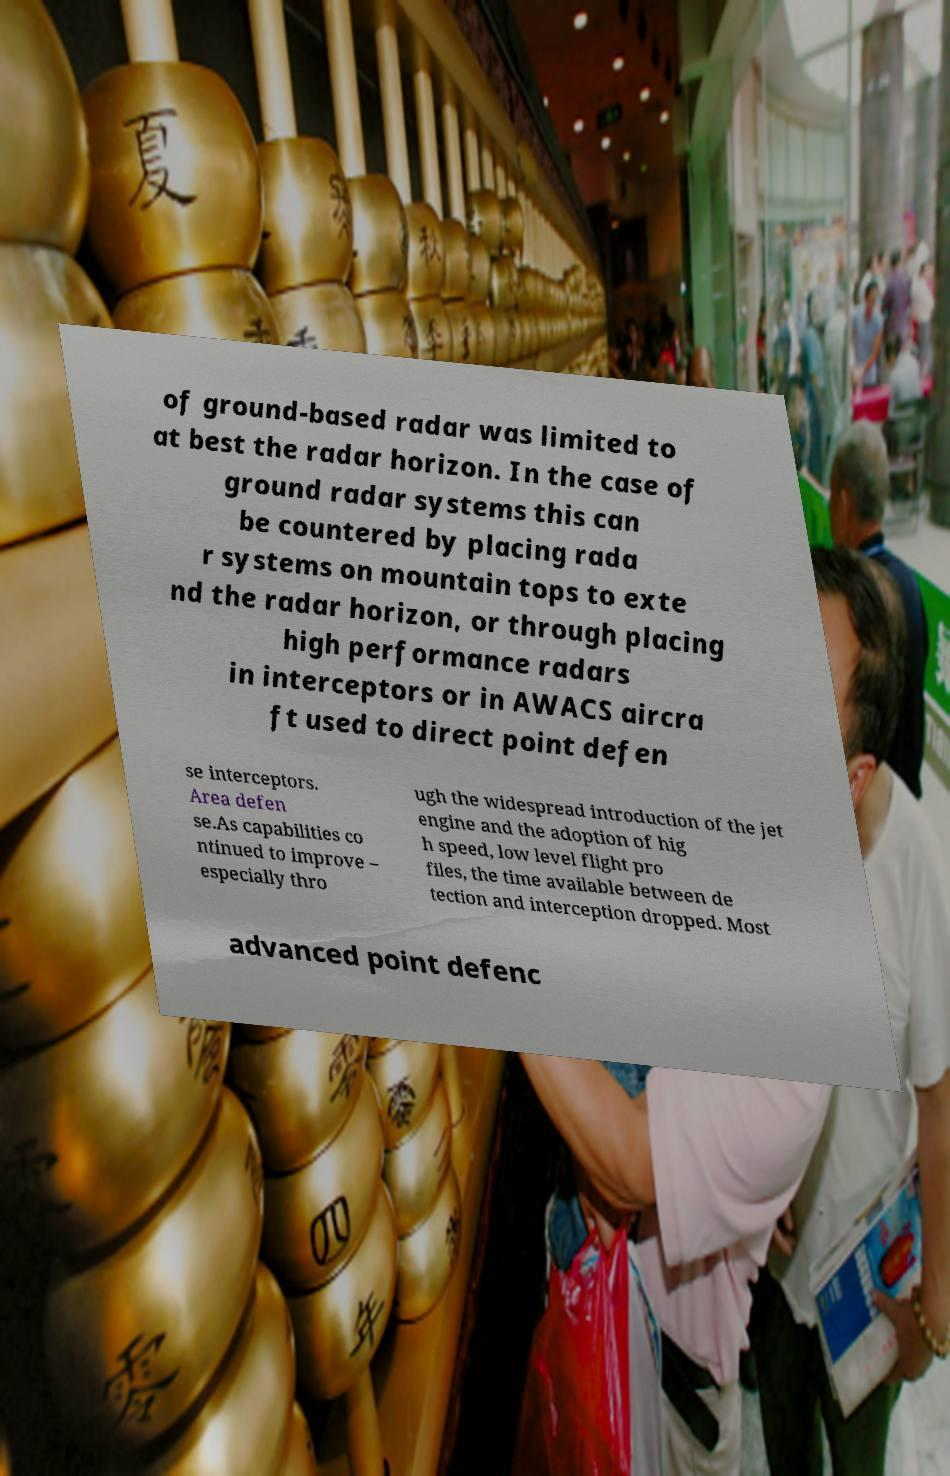Can you read and provide the text displayed in the image?This photo seems to have some interesting text. Can you extract and type it out for me? of ground-based radar was limited to at best the radar horizon. In the case of ground radar systems this can be countered by placing rada r systems on mountain tops to exte nd the radar horizon, or through placing high performance radars in interceptors or in AWACS aircra ft used to direct point defen se interceptors. Area defen se.As capabilities co ntinued to improve – especially thro ugh the widespread introduction of the jet engine and the adoption of hig h speed, low level flight pro files, the time available between de tection and interception dropped. Most advanced point defenc 